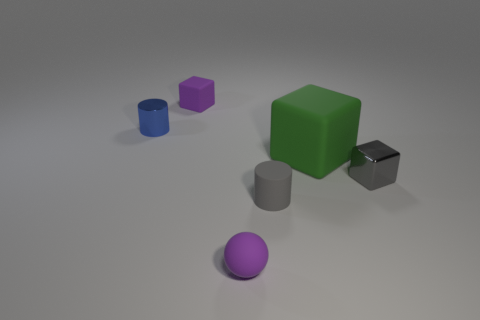Add 2 cyan things. How many objects exist? 8 Subtract all balls. How many objects are left? 5 Subtract all big cyan shiny cylinders. Subtract all tiny rubber things. How many objects are left? 3 Add 3 matte cylinders. How many matte cylinders are left? 4 Add 5 gray shiny spheres. How many gray shiny spheres exist? 5 Subtract 1 gray cylinders. How many objects are left? 5 